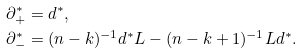Convert formula to latex. <formula><loc_0><loc_0><loc_500><loc_500>\partial ^ { \ast } _ { + } & = d ^ { \ast } , \\ \partial ^ { \ast } _ { - } & = ( n - k ) ^ { - 1 } d ^ { \ast } L - ( n - k + 1 ) ^ { - 1 } L d ^ { \ast } .</formula> 